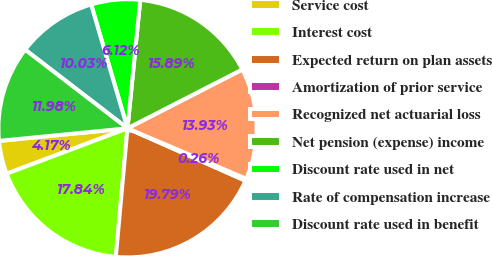Convert chart to OTSL. <chart><loc_0><loc_0><loc_500><loc_500><pie_chart><fcel>Service cost<fcel>Interest cost<fcel>Expected return on plan assets<fcel>Amortization of prior service<fcel>Recognized net actuarial loss<fcel>Net pension (expense) income<fcel>Discount rate used in net<fcel>Rate of compensation increase<fcel>Discount rate used in benefit<nl><fcel>4.17%<fcel>17.84%<fcel>19.79%<fcel>0.26%<fcel>13.93%<fcel>15.89%<fcel>6.12%<fcel>10.03%<fcel>11.98%<nl></chart> 